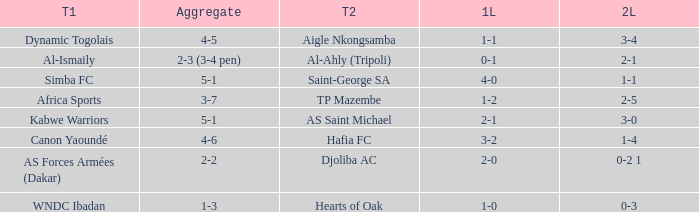What team played against Al-Ismaily (team 1)? Al-Ahly (Tripoli). 